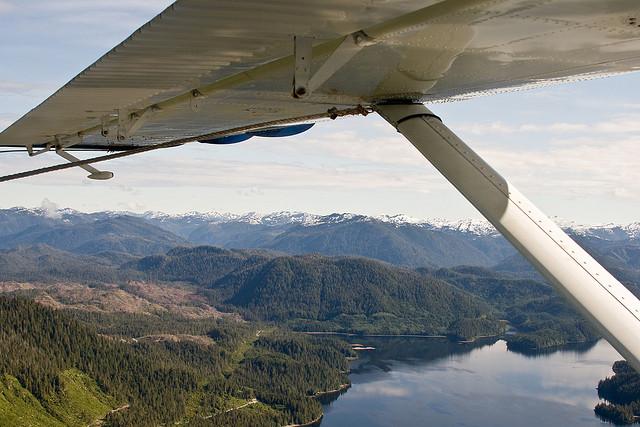What vehicle is the photographer riding on?
Write a very short answer. Plane. What type of body of water is in the picture?
Quick response, please. Lake. Is there snow on the mountains?
Keep it brief. Yes. 